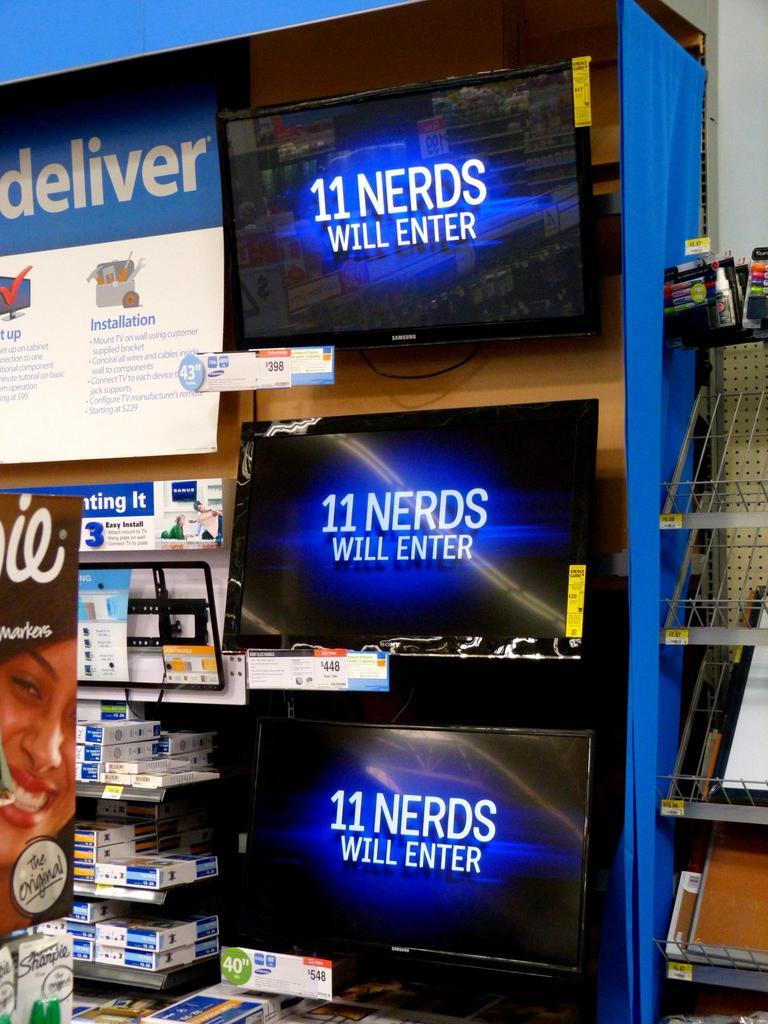What will enter?
Keep it short and to the point. 11 nerds. How many nerds?
Your answer should be very brief. 11. 